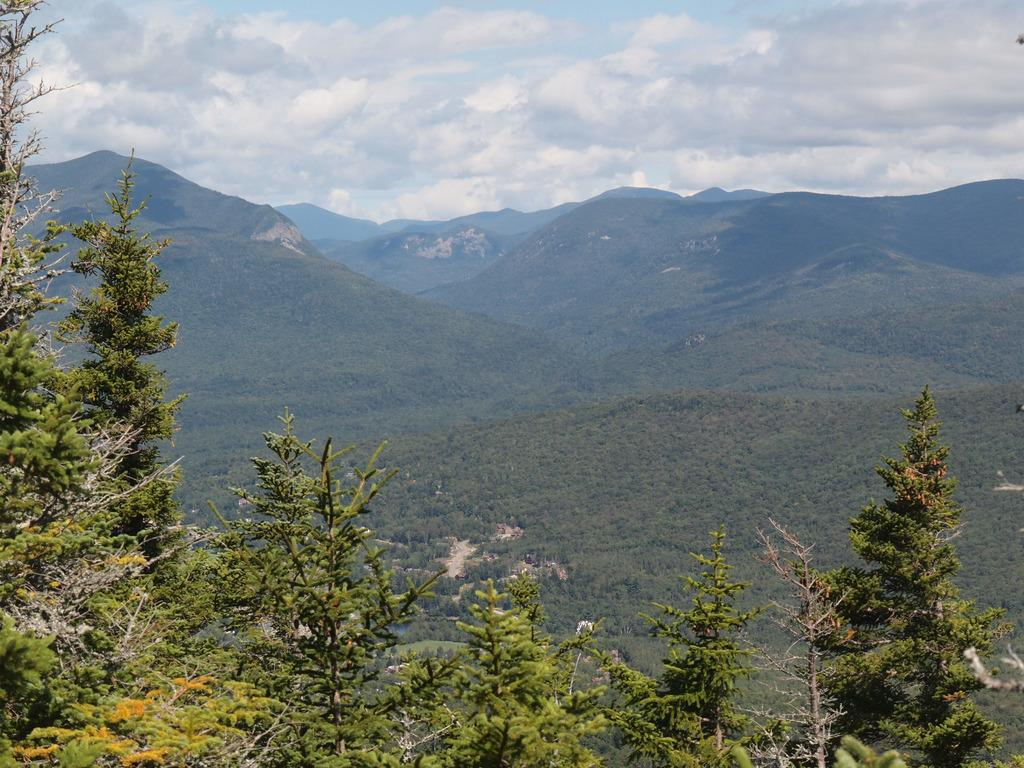What type of vegetation is at the bottom of the image? There are trees at the bottom of the image. What type of geographical feature can be seen in the background of the image? There are mountains in the background of the image. What is visible at the top of the image? The sky is cloudy and visible at the top of the image. What type of acoustics can be heard from the yak in the image? There is no yak present in the image, and therefore no acoustics can be heard from it. What type of coil is visible in the image? There is no coil present in the image. 